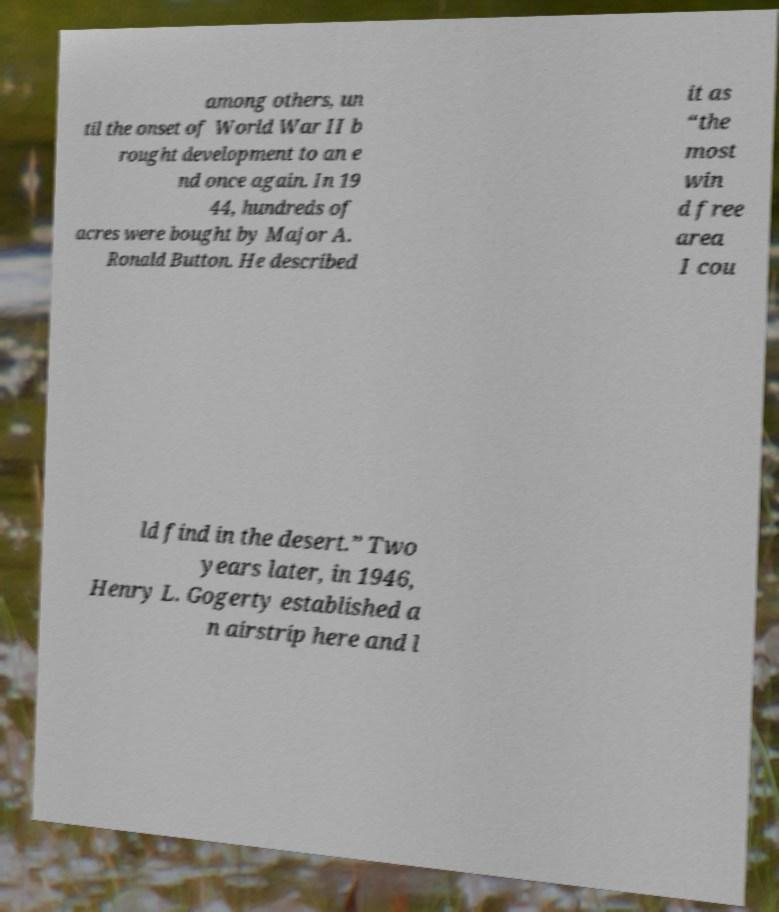Could you assist in decoding the text presented in this image and type it out clearly? among others, un til the onset of World War II b rought development to an e nd once again. In 19 44, hundreds of acres were bought by Major A. Ronald Button. He described it as “the most win d free area I cou ld find in the desert.” Two years later, in 1946, Henry L. Gogerty established a n airstrip here and l 